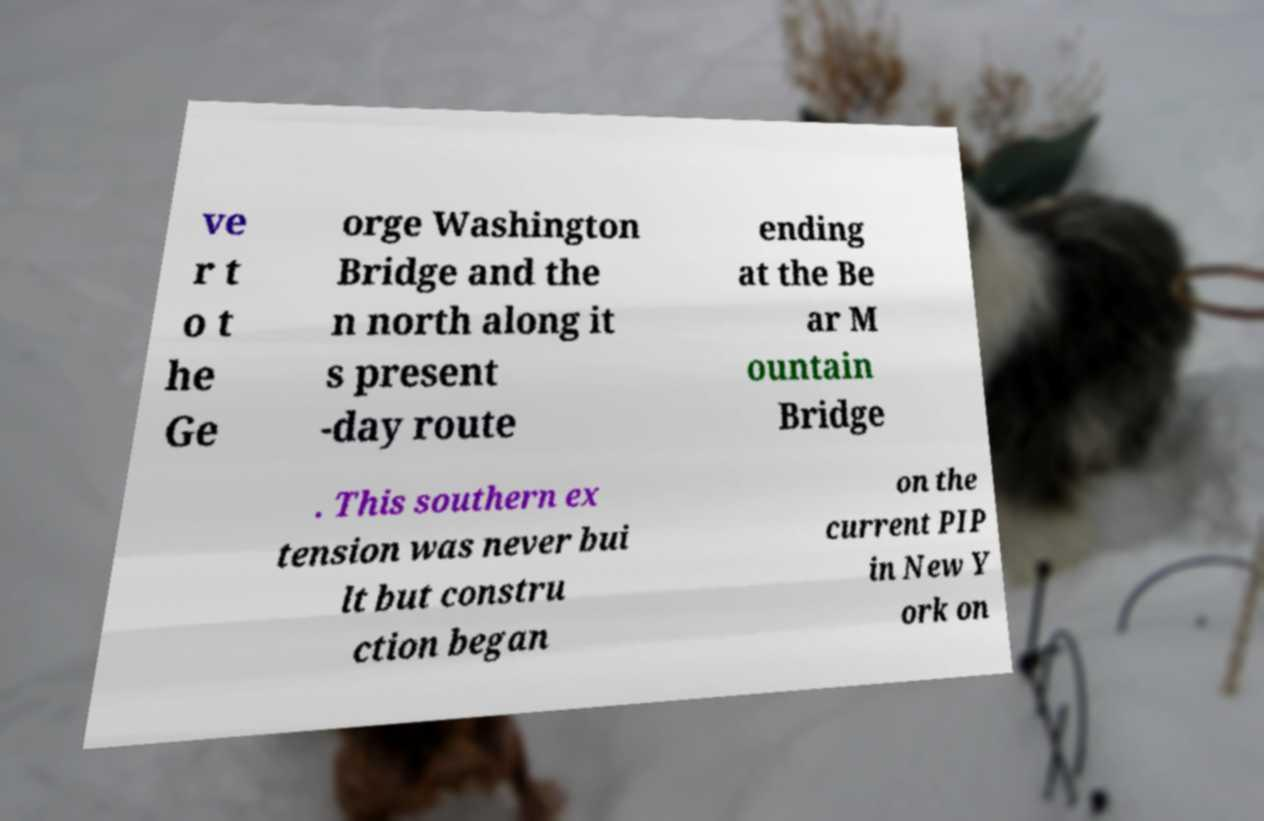What messages or text are displayed in this image? I need them in a readable, typed format. ve r t o t he Ge orge Washington Bridge and the n north along it s present -day route ending at the Be ar M ountain Bridge . This southern ex tension was never bui lt but constru ction began on the current PIP in New Y ork on 